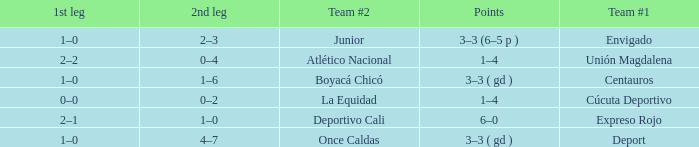What is the 1st leg with a junior team #2? 1–0. 